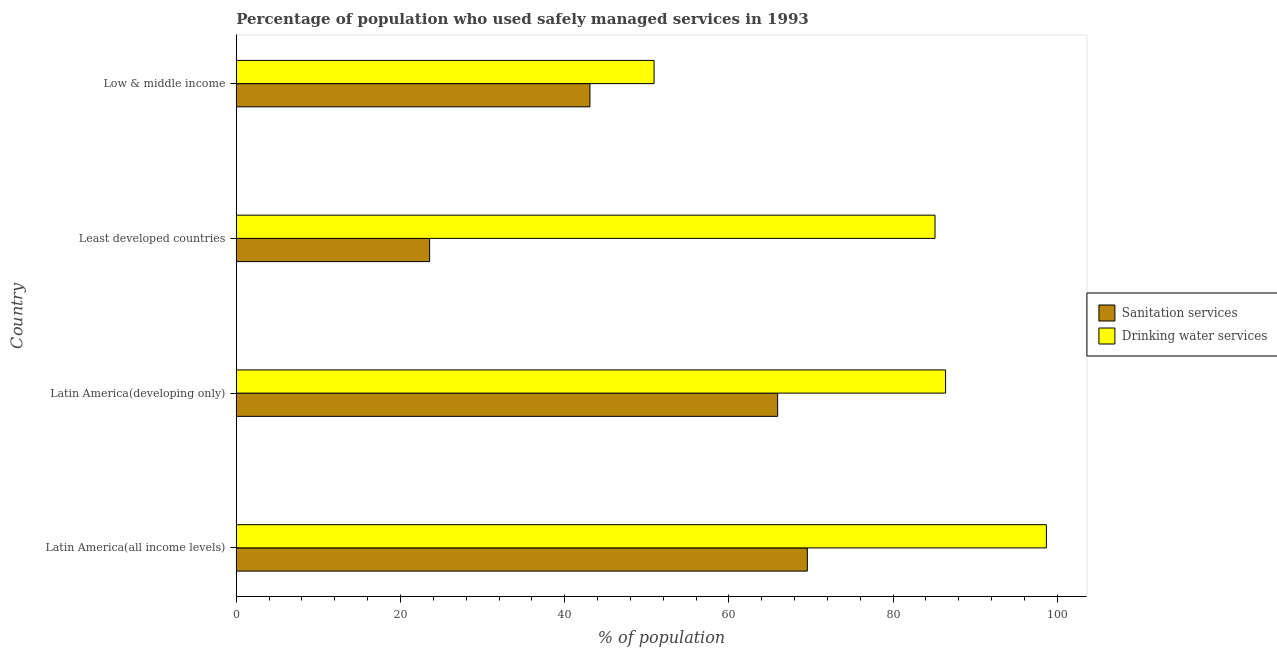How many groups of bars are there?
Provide a succinct answer. 4. Are the number of bars per tick equal to the number of legend labels?
Make the answer very short. Yes. How many bars are there on the 2nd tick from the top?
Your response must be concise. 2. How many bars are there on the 4th tick from the bottom?
Keep it short and to the point. 2. What is the label of the 3rd group of bars from the top?
Your answer should be compact. Latin America(developing only). In how many cases, is the number of bars for a given country not equal to the number of legend labels?
Provide a succinct answer. 0. What is the percentage of population who used drinking water services in Latin America(developing only)?
Provide a succinct answer. 86.39. Across all countries, what is the maximum percentage of population who used drinking water services?
Your response must be concise. 98.67. Across all countries, what is the minimum percentage of population who used sanitation services?
Provide a short and direct response. 23.55. In which country was the percentage of population who used drinking water services maximum?
Give a very brief answer. Latin America(all income levels). In which country was the percentage of population who used sanitation services minimum?
Your response must be concise. Least developed countries. What is the total percentage of population who used sanitation services in the graph?
Offer a terse response. 202.11. What is the difference between the percentage of population who used sanitation services in Latin America(all income levels) and that in Latin America(developing only)?
Your answer should be very brief. 3.62. What is the difference between the percentage of population who used drinking water services in Low & middle income and the percentage of population who used sanitation services in Latin America(all income levels)?
Keep it short and to the point. -18.66. What is the average percentage of population who used sanitation services per country?
Keep it short and to the point. 50.53. What is the difference between the percentage of population who used sanitation services and percentage of population who used drinking water services in Latin America(developing only)?
Give a very brief answer. -20.45. In how many countries, is the percentage of population who used sanitation services greater than 92 %?
Provide a short and direct response. 0. What is the ratio of the percentage of population who used sanitation services in Least developed countries to that in Low & middle income?
Make the answer very short. 0.55. Is the percentage of population who used drinking water services in Latin America(all income levels) less than that in Low & middle income?
Your answer should be compact. No. Is the difference between the percentage of population who used sanitation services in Least developed countries and Low & middle income greater than the difference between the percentage of population who used drinking water services in Least developed countries and Low & middle income?
Offer a terse response. No. What is the difference between the highest and the second highest percentage of population who used sanitation services?
Offer a very short reply. 3.62. What is the difference between the highest and the lowest percentage of population who used sanitation services?
Ensure brevity in your answer.  46.01. In how many countries, is the percentage of population who used drinking water services greater than the average percentage of population who used drinking water services taken over all countries?
Ensure brevity in your answer.  3. What does the 2nd bar from the top in Latin America(all income levels) represents?
Ensure brevity in your answer.  Sanitation services. What does the 2nd bar from the bottom in Latin America(developing only) represents?
Offer a very short reply. Drinking water services. How many bars are there?
Make the answer very short. 8. Are all the bars in the graph horizontal?
Keep it short and to the point. Yes. What is the difference between two consecutive major ticks on the X-axis?
Your answer should be compact. 20. Are the values on the major ticks of X-axis written in scientific E-notation?
Make the answer very short. No. Does the graph contain any zero values?
Provide a succinct answer. No. Where does the legend appear in the graph?
Keep it short and to the point. Center right. What is the title of the graph?
Offer a terse response. Percentage of population who used safely managed services in 1993. Does "Public credit registry" appear as one of the legend labels in the graph?
Your answer should be compact. No. What is the label or title of the X-axis?
Your response must be concise. % of population. What is the label or title of the Y-axis?
Your answer should be compact. Country. What is the % of population of Sanitation services in Latin America(all income levels)?
Offer a very short reply. 69.55. What is the % of population of Drinking water services in Latin America(all income levels)?
Your answer should be very brief. 98.67. What is the % of population of Sanitation services in Latin America(developing only)?
Your response must be concise. 65.94. What is the % of population of Drinking water services in Latin America(developing only)?
Keep it short and to the point. 86.39. What is the % of population of Sanitation services in Least developed countries?
Give a very brief answer. 23.55. What is the % of population in Drinking water services in Least developed countries?
Offer a very short reply. 85.1. What is the % of population of Sanitation services in Low & middle income?
Ensure brevity in your answer.  43.08. What is the % of population in Drinking water services in Low & middle income?
Your answer should be very brief. 50.89. Across all countries, what is the maximum % of population of Sanitation services?
Your answer should be very brief. 69.55. Across all countries, what is the maximum % of population in Drinking water services?
Provide a succinct answer. 98.67. Across all countries, what is the minimum % of population of Sanitation services?
Your answer should be very brief. 23.55. Across all countries, what is the minimum % of population of Drinking water services?
Your answer should be compact. 50.89. What is the total % of population of Sanitation services in the graph?
Your response must be concise. 202.11. What is the total % of population in Drinking water services in the graph?
Your answer should be very brief. 321.05. What is the difference between the % of population in Sanitation services in Latin America(all income levels) and that in Latin America(developing only)?
Offer a terse response. 3.62. What is the difference between the % of population in Drinking water services in Latin America(all income levels) and that in Latin America(developing only)?
Provide a succinct answer. 12.28. What is the difference between the % of population of Sanitation services in Latin America(all income levels) and that in Least developed countries?
Your response must be concise. 46.01. What is the difference between the % of population in Drinking water services in Latin America(all income levels) and that in Least developed countries?
Your response must be concise. 13.57. What is the difference between the % of population of Sanitation services in Latin America(all income levels) and that in Low & middle income?
Your response must be concise. 26.48. What is the difference between the % of population in Drinking water services in Latin America(all income levels) and that in Low & middle income?
Offer a very short reply. 47.78. What is the difference between the % of population in Sanitation services in Latin America(developing only) and that in Least developed countries?
Offer a terse response. 42.39. What is the difference between the % of population in Drinking water services in Latin America(developing only) and that in Least developed countries?
Provide a succinct answer. 1.29. What is the difference between the % of population in Sanitation services in Latin America(developing only) and that in Low & middle income?
Your answer should be compact. 22.86. What is the difference between the % of population in Drinking water services in Latin America(developing only) and that in Low & middle income?
Your answer should be very brief. 35.5. What is the difference between the % of population of Sanitation services in Least developed countries and that in Low & middle income?
Give a very brief answer. -19.53. What is the difference between the % of population in Drinking water services in Least developed countries and that in Low & middle income?
Offer a very short reply. 34.22. What is the difference between the % of population of Sanitation services in Latin America(all income levels) and the % of population of Drinking water services in Latin America(developing only)?
Offer a terse response. -16.84. What is the difference between the % of population of Sanitation services in Latin America(all income levels) and the % of population of Drinking water services in Least developed countries?
Offer a very short reply. -15.55. What is the difference between the % of population of Sanitation services in Latin America(all income levels) and the % of population of Drinking water services in Low & middle income?
Give a very brief answer. 18.66. What is the difference between the % of population in Sanitation services in Latin America(developing only) and the % of population in Drinking water services in Least developed countries?
Keep it short and to the point. -19.17. What is the difference between the % of population of Sanitation services in Latin America(developing only) and the % of population of Drinking water services in Low & middle income?
Your answer should be compact. 15.05. What is the difference between the % of population of Sanitation services in Least developed countries and the % of population of Drinking water services in Low & middle income?
Keep it short and to the point. -27.34. What is the average % of population in Sanitation services per country?
Provide a short and direct response. 50.53. What is the average % of population in Drinking water services per country?
Your response must be concise. 80.26. What is the difference between the % of population in Sanitation services and % of population in Drinking water services in Latin America(all income levels)?
Offer a very short reply. -29.12. What is the difference between the % of population of Sanitation services and % of population of Drinking water services in Latin America(developing only)?
Keep it short and to the point. -20.45. What is the difference between the % of population of Sanitation services and % of population of Drinking water services in Least developed countries?
Keep it short and to the point. -61.56. What is the difference between the % of population of Sanitation services and % of population of Drinking water services in Low & middle income?
Provide a succinct answer. -7.81. What is the ratio of the % of population of Sanitation services in Latin America(all income levels) to that in Latin America(developing only)?
Provide a short and direct response. 1.05. What is the ratio of the % of population in Drinking water services in Latin America(all income levels) to that in Latin America(developing only)?
Ensure brevity in your answer.  1.14. What is the ratio of the % of population of Sanitation services in Latin America(all income levels) to that in Least developed countries?
Make the answer very short. 2.95. What is the ratio of the % of population in Drinking water services in Latin America(all income levels) to that in Least developed countries?
Give a very brief answer. 1.16. What is the ratio of the % of population of Sanitation services in Latin America(all income levels) to that in Low & middle income?
Offer a terse response. 1.61. What is the ratio of the % of population in Drinking water services in Latin America(all income levels) to that in Low & middle income?
Provide a succinct answer. 1.94. What is the ratio of the % of population in Sanitation services in Latin America(developing only) to that in Least developed countries?
Keep it short and to the point. 2.8. What is the ratio of the % of population in Drinking water services in Latin America(developing only) to that in Least developed countries?
Ensure brevity in your answer.  1.02. What is the ratio of the % of population of Sanitation services in Latin America(developing only) to that in Low & middle income?
Provide a short and direct response. 1.53. What is the ratio of the % of population of Drinking water services in Latin America(developing only) to that in Low & middle income?
Your answer should be compact. 1.7. What is the ratio of the % of population in Sanitation services in Least developed countries to that in Low & middle income?
Provide a short and direct response. 0.55. What is the ratio of the % of population in Drinking water services in Least developed countries to that in Low & middle income?
Keep it short and to the point. 1.67. What is the difference between the highest and the second highest % of population of Sanitation services?
Make the answer very short. 3.62. What is the difference between the highest and the second highest % of population in Drinking water services?
Your answer should be very brief. 12.28. What is the difference between the highest and the lowest % of population of Sanitation services?
Make the answer very short. 46.01. What is the difference between the highest and the lowest % of population in Drinking water services?
Provide a succinct answer. 47.78. 